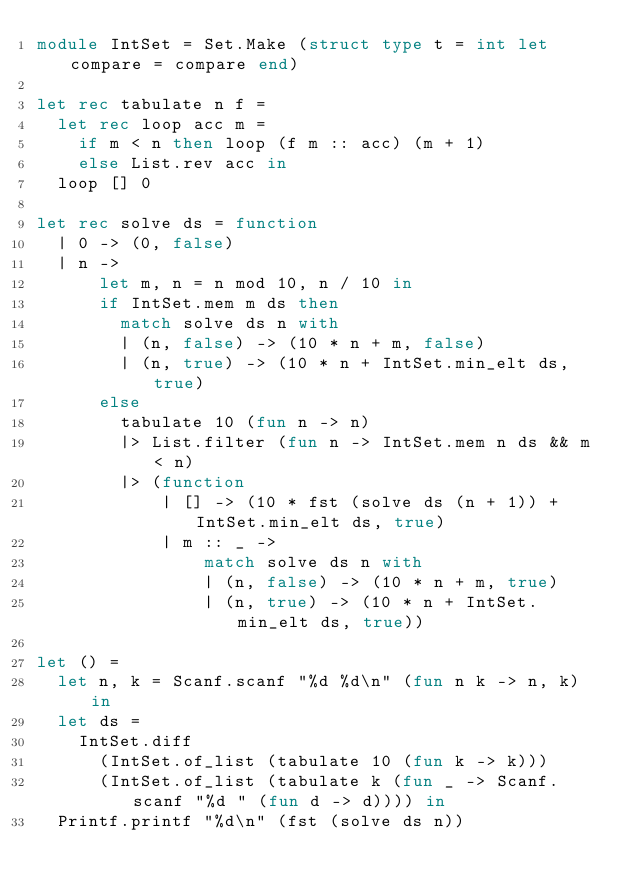Convert code to text. <code><loc_0><loc_0><loc_500><loc_500><_OCaml_>module IntSet = Set.Make (struct type t = int let compare = compare end)

let rec tabulate n f = 
  let rec loop acc m =
    if m < n then loop (f m :: acc) (m + 1)
    else List.rev acc in
  loop [] 0

let rec solve ds = function
  | 0 -> (0, false)
  | n ->
      let m, n = n mod 10, n / 10 in
      if IntSet.mem m ds then
        match solve ds n with
        | (n, false) -> (10 * n + m, false)
        | (n, true) -> (10 * n + IntSet.min_elt ds, true)
      else
        tabulate 10 (fun n -> n)
        |> List.filter (fun n -> IntSet.mem n ds && m < n)
        |> (function
            | [] -> (10 * fst (solve ds (n + 1)) + IntSet.min_elt ds, true)
            | m :: _ ->
                match solve ds n with
                | (n, false) -> (10 * n + m, true)
                | (n, true) -> (10 * n + IntSet.min_elt ds, true))

let () =
  let n, k = Scanf.scanf "%d %d\n" (fun n k -> n, k) in
  let ds =
    IntSet.diff
      (IntSet.of_list (tabulate 10 (fun k -> k)))
      (IntSet.of_list (tabulate k (fun _ -> Scanf.scanf "%d " (fun d -> d)))) in
  Printf.printf "%d\n" (fst (solve ds n))
</code> 